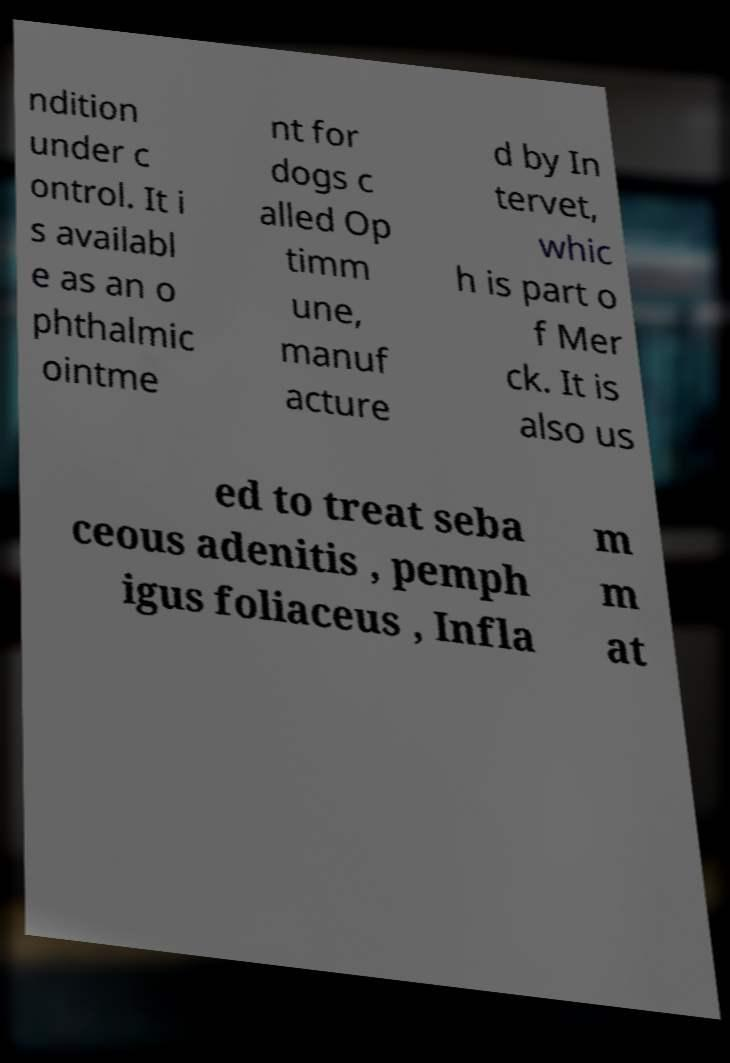Can you accurately transcribe the text from the provided image for me? ndition under c ontrol. It i s availabl e as an o phthalmic ointme nt for dogs c alled Op timm une, manuf acture d by In tervet, whic h is part o f Mer ck. It is also us ed to treat seba ceous adenitis , pemph igus foliaceus , Infla m m at 